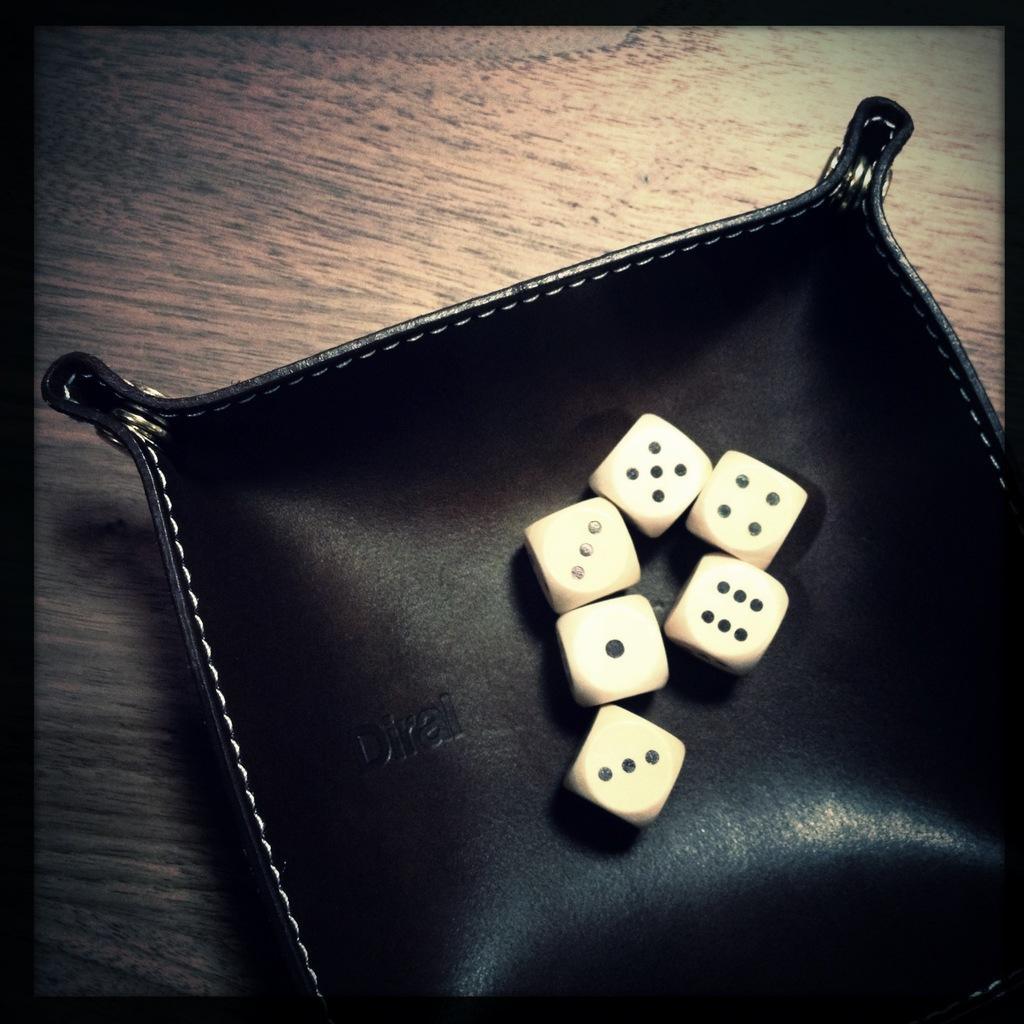Can you describe this image briefly? In this picture we can see six dices placed on a black color object. 